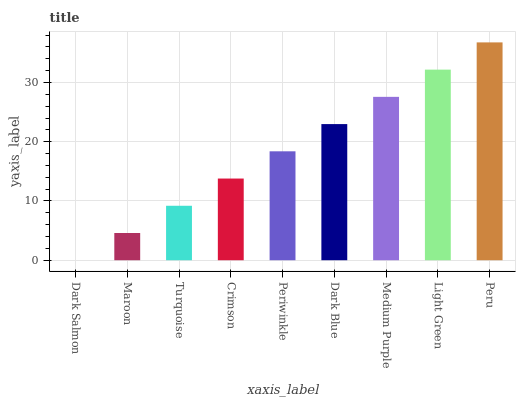Is Dark Salmon the minimum?
Answer yes or no. Yes. Is Peru the maximum?
Answer yes or no. Yes. Is Maroon the minimum?
Answer yes or no. No. Is Maroon the maximum?
Answer yes or no. No. Is Maroon greater than Dark Salmon?
Answer yes or no. Yes. Is Dark Salmon less than Maroon?
Answer yes or no. Yes. Is Dark Salmon greater than Maroon?
Answer yes or no. No. Is Maroon less than Dark Salmon?
Answer yes or no. No. Is Periwinkle the high median?
Answer yes or no. Yes. Is Periwinkle the low median?
Answer yes or no. Yes. Is Turquoise the high median?
Answer yes or no. No. Is Medium Purple the low median?
Answer yes or no. No. 